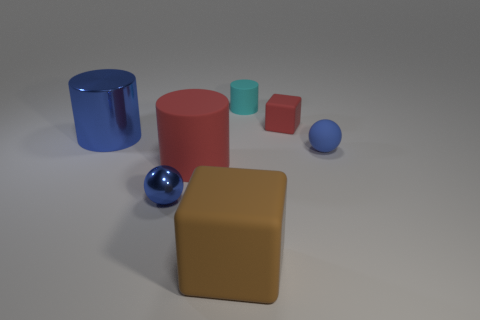The other object that is the same shape as the brown rubber thing is what size?
Provide a succinct answer. Small. Do the rubber sphere and the big matte cylinder have the same color?
Offer a very short reply. No. The object that is both in front of the large red matte cylinder and to the left of the large brown matte block is what color?
Ensure brevity in your answer.  Blue. What number of objects are tiny objects on the right side of the tiny cube or large metal cylinders?
Your response must be concise. 2. There is another small matte thing that is the same shape as the brown rubber object; what is its color?
Your response must be concise. Red. There is a cyan rubber thing; is its shape the same as the tiny blue thing that is on the left side of the blue matte sphere?
Offer a terse response. No. How many objects are matte objects that are behind the large brown block or blue matte spheres that are behind the large brown rubber cube?
Give a very brief answer. 4. Are there fewer red matte cylinders that are behind the small cylinder than cyan cylinders?
Offer a very short reply. Yes. Is the material of the cyan cylinder the same as the large cylinder to the right of the large blue thing?
Give a very brief answer. Yes. What material is the cyan cylinder?
Keep it short and to the point. Rubber. 